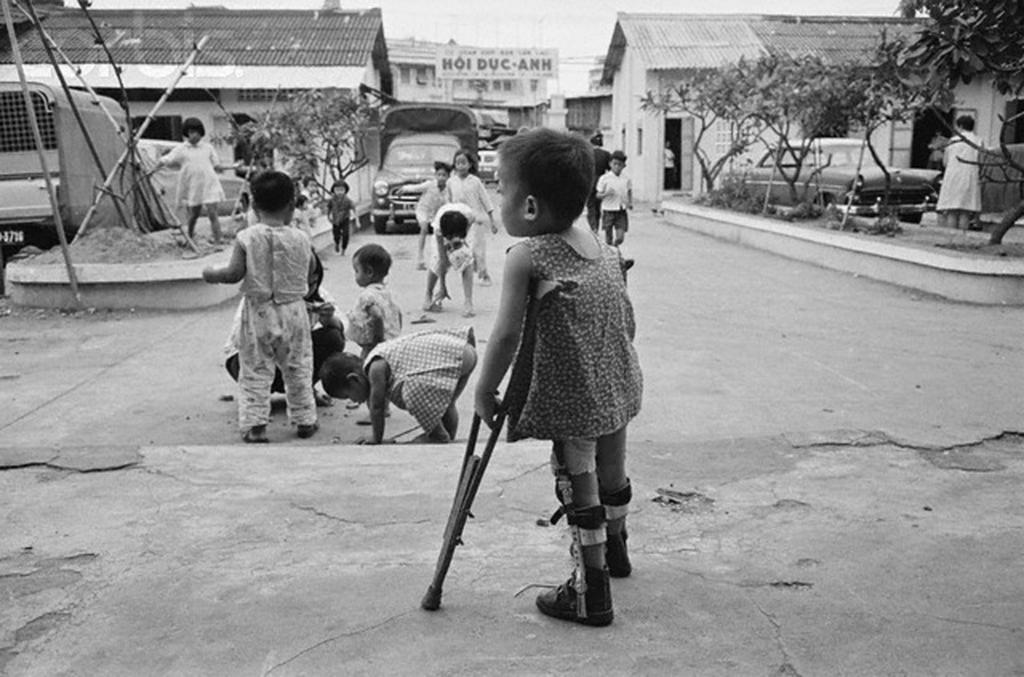Can you describe this image briefly? In this picture we can see few people are on the road, side we can see some houses, trees along with few vehicles. 